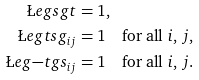<formula> <loc_0><loc_0><loc_500><loc_500>\L e g { s g } { t } & = 1 , \\ \L e g { t s } { g _ { i j } } & = 1 \quad \text {for all $i$, $j$} , \\ \L e g { - t g } { s _ { i j } } & = 1 \quad \text {for all $i$, $j$} .</formula> 